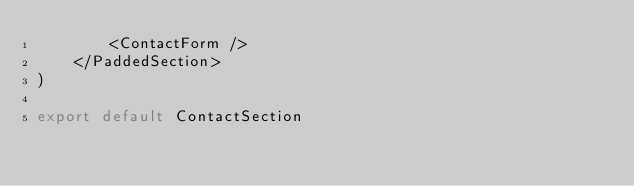Convert code to text. <code><loc_0><loc_0><loc_500><loc_500><_JavaScript_>        <ContactForm />
    </PaddedSection>
)

export default ContactSection

</code> 